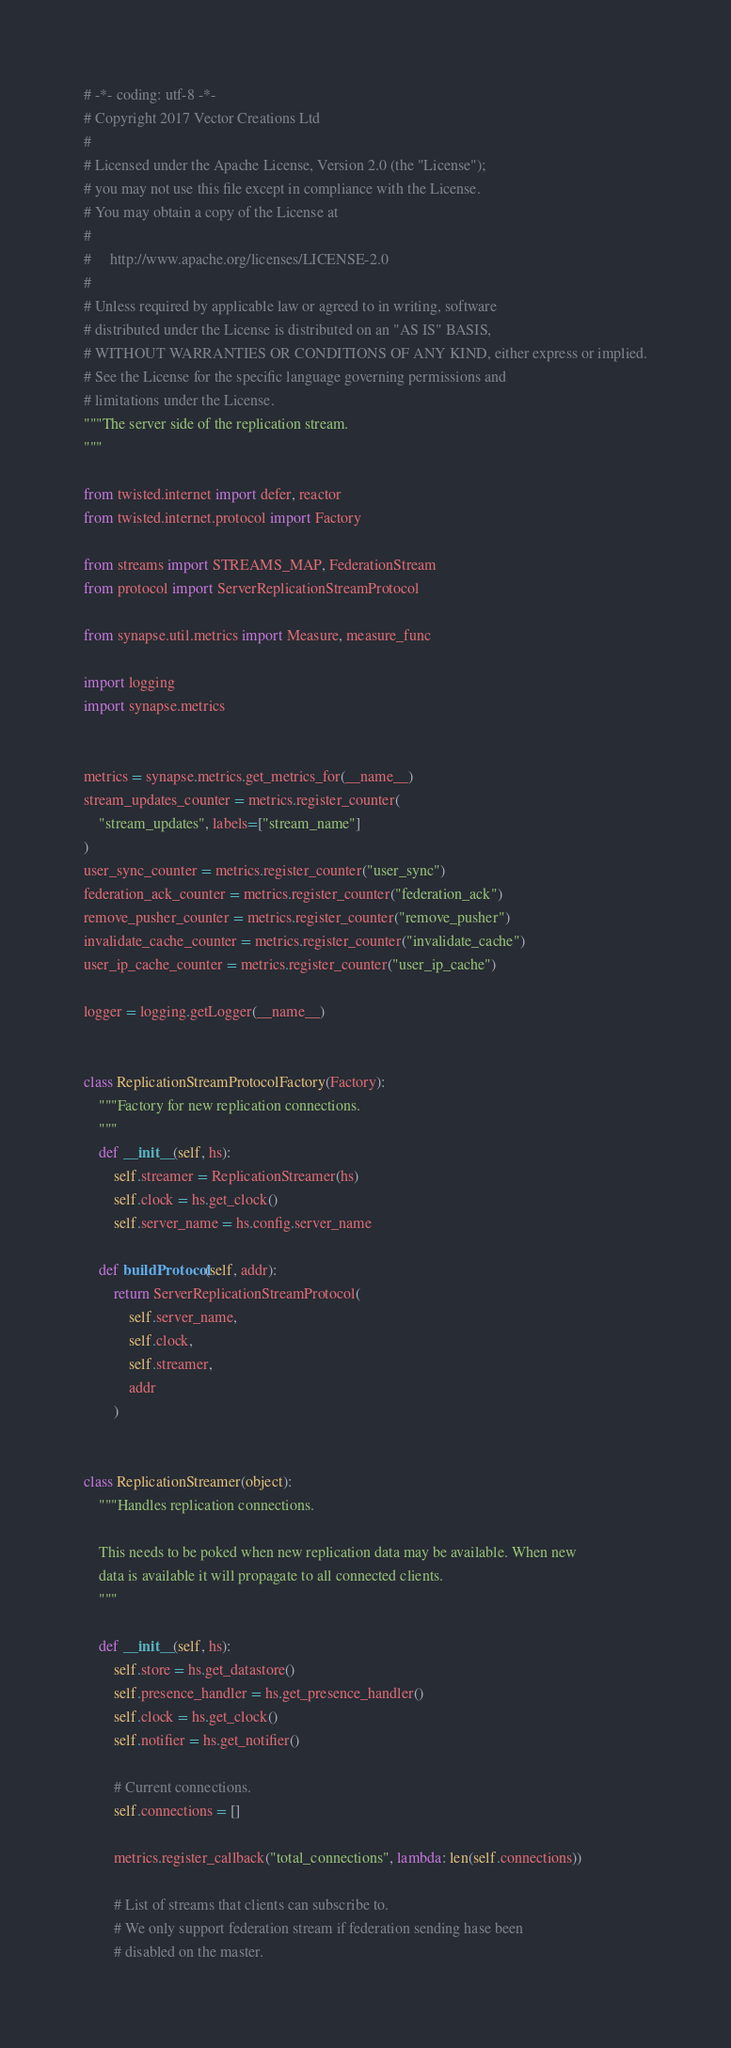Convert code to text. <code><loc_0><loc_0><loc_500><loc_500><_Python_># -*- coding: utf-8 -*-
# Copyright 2017 Vector Creations Ltd
#
# Licensed under the Apache License, Version 2.0 (the "License");
# you may not use this file except in compliance with the License.
# You may obtain a copy of the License at
#
#     http://www.apache.org/licenses/LICENSE-2.0
#
# Unless required by applicable law or agreed to in writing, software
# distributed under the License is distributed on an "AS IS" BASIS,
# WITHOUT WARRANTIES OR CONDITIONS OF ANY KIND, either express or implied.
# See the License for the specific language governing permissions and
# limitations under the License.
"""The server side of the replication stream.
"""

from twisted.internet import defer, reactor
from twisted.internet.protocol import Factory

from streams import STREAMS_MAP, FederationStream
from protocol import ServerReplicationStreamProtocol

from synapse.util.metrics import Measure, measure_func

import logging
import synapse.metrics


metrics = synapse.metrics.get_metrics_for(__name__)
stream_updates_counter = metrics.register_counter(
    "stream_updates", labels=["stream_name"]
)
user_sync_counter = metrics.register_counter("user_sync")
federation_ack_counter = metrics.register_counter("federation_ack")
remove_pusher_counter = metrics.register_counter("remove_pusher")
invalidate_cache_counter = metrics.register_counter("invalidate_cache")
user_ip_cache_counter = metrics.register_counter("user_ip_cache")

logger = logging.getLogger(__name__)


class ReplicationStreamProtocolFactory(Factory):
    """Factory for new replication connections.
    """
    def __init__(self, hs):
        self.streamer = ReplicationStreamer(hs)
        self.clock = hs.get_clock()
        self.server_name = hs.config.server_name

    def buildProtocol(self, addr):
        return ServerReplicationStreamProtocol(
            self.server_name,
            self.clock,
            self.streamer,
            addr
        )


class ReplicationStreamer(object):
    """Handles replication connections.

    This needs to be poked when new replication data may be available. When new
    data is available it will propagate to all connected clients.
    """

    def __init__(self, hs):
        self.store = hs.get_datastore()
        self.presence_handler = hs.get_presence_handler()
        self.clock = hs.get_clock()
        self.notifier = hs.get_notifier()

        # Current connections.
        self.connections = []

        metrics.register_callback("total_connections", lambda: len(self.connections))

        # List of streams that clients can subscribe to.
        # We only support federation stream if federation sending hase been
        # disabled on the master.</code> 